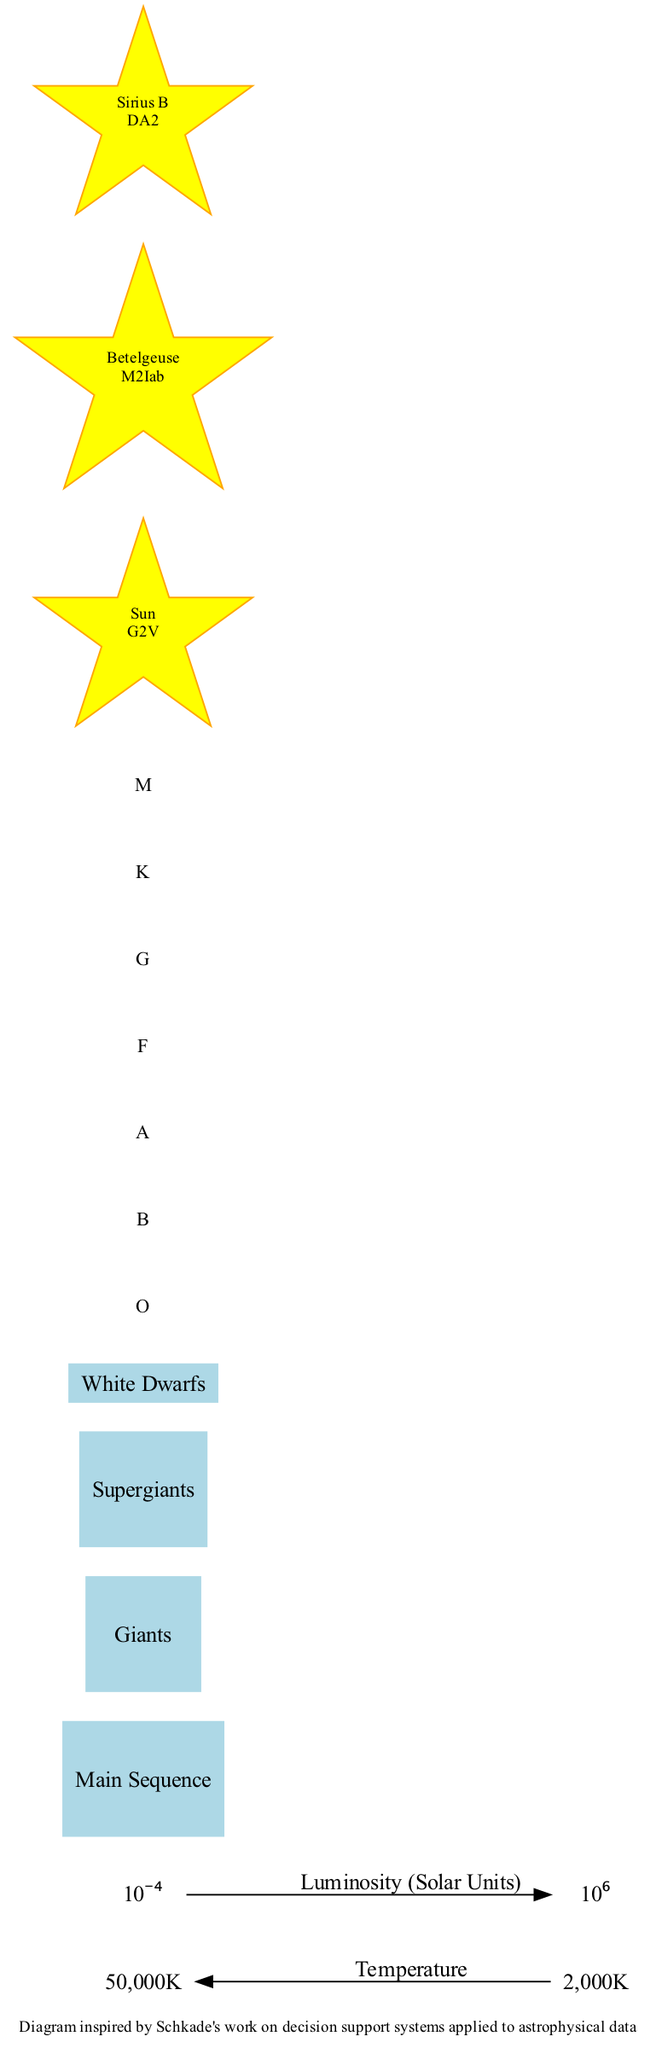What is the highest spectral class represented in the diagram? The spectral types listed in the diagram are O, B, A, F, G, K, and M. Among these, O is the highest in terms of temperature and luminosity.
Answer: O Where is the Sun located in the Hertzsprung-Russell diagram? According to the diagram, the Sun is positioned at the center of the Main Sequence, which is a diagonal band located from the bottom-right to the top-left of the diagram.
Answer: Center of Main Sequence What is the position of Supergiants in the diagram? The Supergiants are located at the top of the diagram, indicating their high luminosity compared to other star classes.
Answer: Top of diagram How many star classes are illustrated in the diagram? The diagram shows four distinct star classes: Main Sequence, Giants, Supergiants, and White Dwarfs.
Answer: Four What is the temperature range represented along the horizontal axis? The horizontal axis of the diagram represents a temperature range from 50,000 Kelvin on the left to 2,000 Kelvin on the right.
Answer: 50,000K to 2,000K Which notable star is classified as a White Dwarf? Among the notable stars listed in the diagram, Sirius B is identified as a White Dwarf with the classification DA2.
Answer: Sirius B How does the luminosity of Supergiants compare to that of White Dwarfs? Supergiants are positioned at the top of the diagram, indicating they possess much greater luminosity than White Dwarfs, which are located in the bottom-left quadrant of the diagram.
Answer: Greater luminosity What spectral class is represented at the center of the Main Sequence? The center of the Main Sequence is occupied by the Sun, which has a spectral classification of G2V.
Answer: G2V What is the general trend of temperature as one moves from the bottom-right to the top-left of the diagram? As one moves from the bottom-right to the top-left of the diagram, the temperature generally increases, indicating hotter stars are located toward the left side.
Answer: Increases 